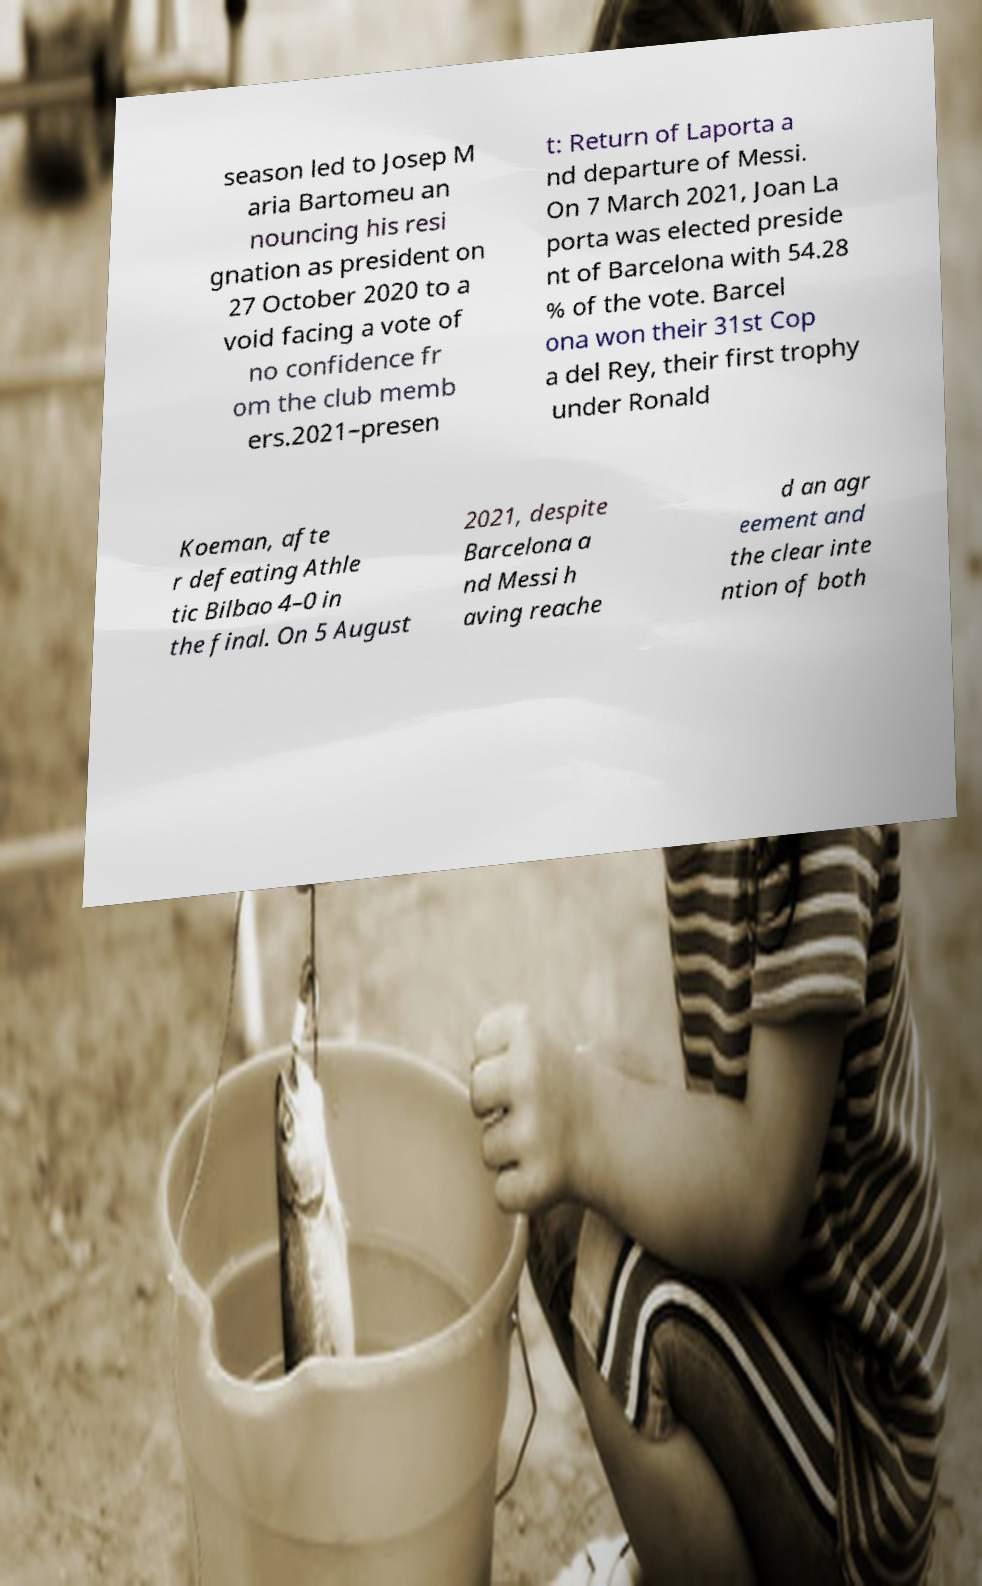What messages or text are displayed in this image? I need them in a readable, typed format. season led to Josep M aria Bartomeu an nouncing his resi gnation as president on 27 October 2020 to a void facing a vote of no confidence fr om the club memb ers.2021–presen t: Return of Laporta a nd departure of Messi. On 7 March 2021, Joan La porta was elected preside nt of Barcelona with 54.28 % of the vote. Barcel ona won their 31st Cop a del Rey, their first trophy under Ronald Koeman, afte r defeating Athle tic Bilbao 4–0 in the final. On 5 August 2021, despite Barcelona a nd Messi h aving reache d an agr eement and the clear inte ntion of both 